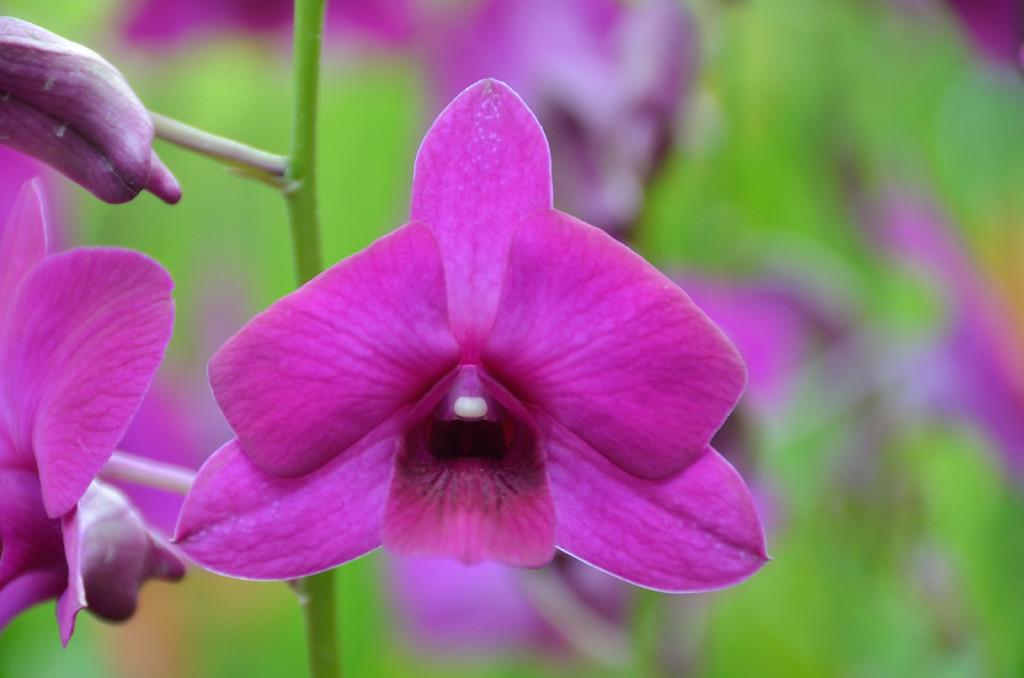What type of plants can be seen in the image? There are flowers in the image. What color are the flowers in the image? The flowers are purple in color. Can you describe any part of the flowers besides the petals? Yes, there is a stem visible in the background of the image. What type of porter is carrying the flowers in the image? There is no porter carrying the flowers in the image; the flowers are likely in a vase or container. What condition is the push button in within the image? There is no push button present in the image. 